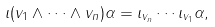<formula> <loc_0><loc_0><loc_500><loc_500>\iota ( v _ { 1 } \wedge \cdots \wedge v _ { n } ) \alpha = \iota _ { v _ { n } } \cdots \iota _ { v _ { 1 } } \alpha ,</formula> 